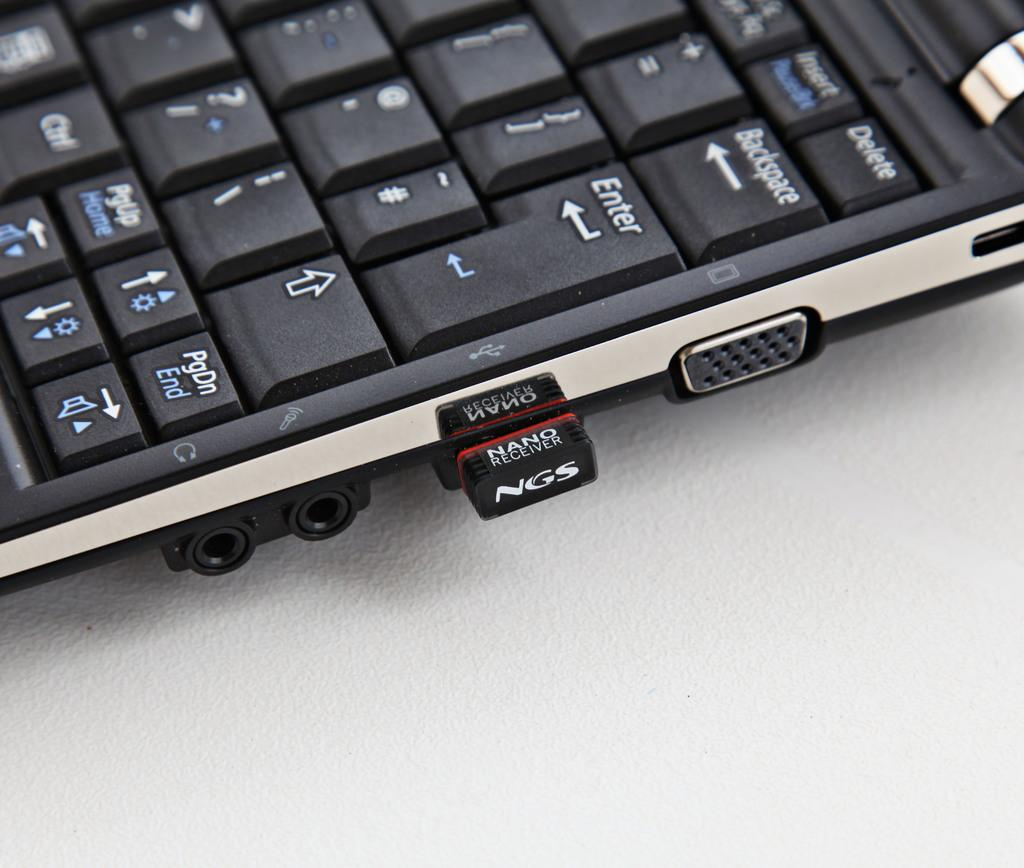Provide a one-sentence caption for the provided image. A "NGS Nano" flash drive hangs out of a laptop. 